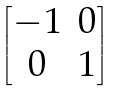Convert formula to latex. <formula><loc_0><loc_0><loc_500><loc_500>\begin{bmatrix} - 1 & 0 \\ 0 & 1 \\ \end{bmatrix}</formula> 